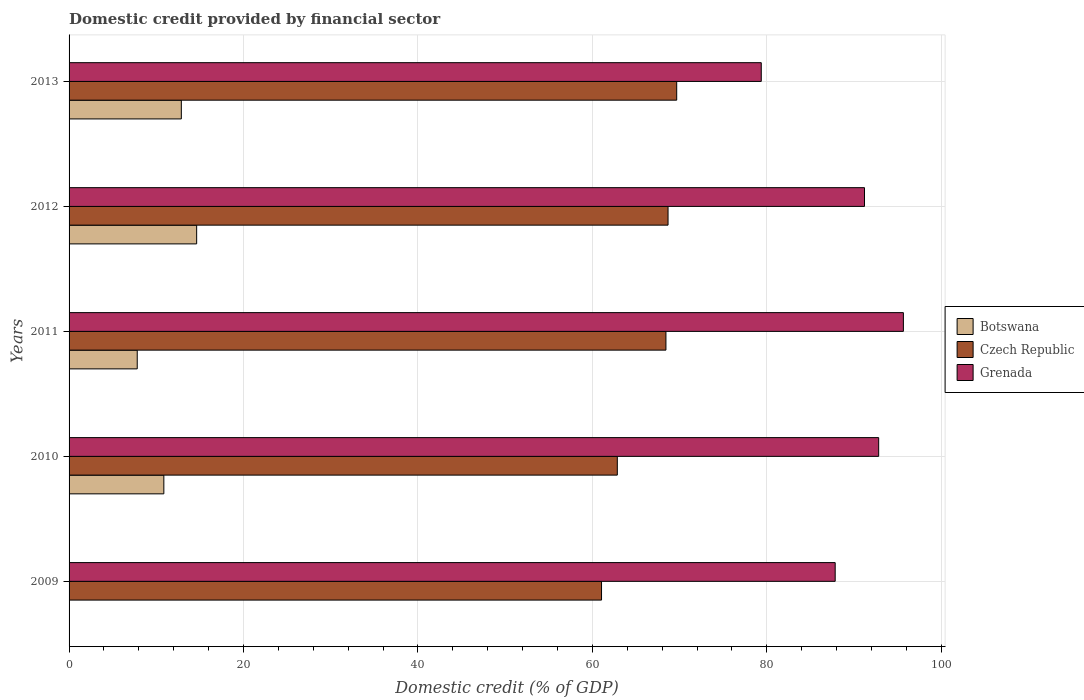Are the number of bars per tick equal to the number of legend labels?
Offer a very short reply. No. Are the number of bars on each tick of the Y-axis equal?
Offer a very short reply. No. What is the domestic credit in Grenada in 2010?
Provide a short and direct response. 92.83. Across all years, what is the maximum domestic credit in Grenada?
Your response must be concise. 95.66. In which year was the domestic credit in Grenada maximum?
Give a very brief answer. 2011. What is the total domestic credit in Czech Republic in the graph?
Make the answer very short. 330.69. What is the difference between the domestic credit in Botswana in 2011 and that in 2012?
Ensure brevity in your answer.  -6.81. What is the difference between the domestic credit in Botswana in 2011 and the domestic credit in Grenada in 2013?
Keep it short and to the point. -71.55. What is the average domestic credit in Grenada per year?
Your response must be concise. 89.38. In the year 2011, what is the difference between the domestic credit in Botswana and domestic credit in Czech Republic?
Provide a short and direct response. -60.62. In how many years, is the domestic credit in Botswana greater than 84 %?
Offer a terse response. 0. What is the ratio of the domestic credit in Botswana in 2011 to that in 2012?
Ensure brevity in your answer.  0.53. Is the domestic credit in Botswana in 2011 less than that in 2013?
Provide a short and direct response. Yes. What is the difference between the highest and the second highest domestic credit in Czech Republic?
Your response must be concise. 0.99. What is the difference between the highest and the lowest domestic credit in Botswana?
Ensure brevity in your answer.  14.63. In how many years, is the domestic credit in Grenada greater than the average domestic credit in Grenada taken over all years?
Your response must be concise. 3. Is it the case that in every year, the sum of the domestic credit in Botswana and domestic credit in Grenada is greater than the domestic credit in Czech Republic?
Give a very brief answer. Yes. How many years are there in the graph?
Ensure brevity in your answer.  5. What is the difference between two consecutive major ticks on the X-axis?
Make the answer very short. 20. Does the graph contain any zero values?
Provide a short and direct response. Yes. Does the graph contain grids?
Keep it short and to the point. Yes. What is the title of the graph?
Give a very brief answer. Domestic credit provided by financial sector. What is the label or title of the X-axis?
Provide a succinct answer. Domestic credit (% of GDP). What is the Domestic credit (% of GDP) in Czech Republic in 2009?
Offer a terse response. 61.05. What is the Domestic credit (% of GDP) in Grenada in 2009?
Provide a succinct answer. 87.84. What is the Domestic credit (% of GDP) in Botswana in 2010?
Offer a very short reply. 10.87. What is the Domestic credit (% of GDP) in Czech Republic in 2010?
Provide a succinct answer. 62.86. What is the Domestic credit (% of GDP) in Grenada in 2010?
Make the answer very short. 92.83. What is the Domestic credit (% of GDP) of Botswana in 2011?
Ensure brevity in your answer.  7.82. What is the Domestic credit (% of GDP) in Czech Republic in 2011?
Give a very brief answer. 68.44. What is the Domestic credit (% of GDP) of Grenada in 2011?
Your answer should be very brief. 95.66. What is the Domestic credit (% of GDP) of Botswana in 2012?
Your answer should be very brief. 14.63. What is the Domestic credit (% of GDP) in Czech Republic in 2012?
Provide a succinct answer. 68.68. What is the Domestic credit (% of GDP) in Grenada in 2012?
Offer a very short reply. 91.2. What is the Domestic credit (% of GDP) in Botswana in 2013?
Provide a succinct answer. 12.87. What is the Domestic credit (% of GDP) of Czech Republic in 2013?
Offer a very short reply. 69.67. What is the Domestic credit (% of GDP) of Grenada in 2013?
Provide a succinct answer. 79.37. Across all years, what is the maximum Domestic credit (% of GDP) in Botswana?
Ensure brevity in your answer.  14.63. Across all years, what is the maximum Domestic credit (% of GDP) of Czech Republic?
Offer a terse response. 69.67. Across all years, what is the maximum Domestic credit (% of GDP) in Grenada?
Your answer should be compact. 95.66. Across all years, what is the minimum Domestic credit (% of GDP) in Botswana?
Your answer should be very brief. 0. Across all years, what is the minimum Domestic credit (% of GDP) in Czech Republic?
Your response must be concise. 61.05. Across all years, what is the minimum Domestic credit (% of GDP) in Grenada?
Provide a succinct answer. 79.37. What is the total Domestic credit (% of GDP) of Botswana in the graph?
Provide a short and direct response. 46.18. What is the total Domestic credit (% of GDP) in Czech Republic in the graph?
Keep it short and to the point. 330.69. What is the total Domestic credit (% of GDP) in Grenada in the graph?
Offer a terse response. 446.9. What is the difference between the Domestic credit (% of GDP) in Czech Republic in 2009 and that in 2010?
Your answer should be compact. -1.81. What is the difference between the Domestic credit (% of GDP) of Grenada in 2009 and that in 2010?
Your answer should be compact. -4.99. What is the difference between the Domestic credit (% of GDP) of Czech Republic in 2009 and that in 2011?
Make the answer very short. -7.39. What is the difference between the Domestic credit (% of GDP) of Grenada in 2009 and that in 2011?
Your answer should be very brief. -7.82. What is the difference between the Domestic credit (% of GDP) in Czech Republic in 2009 and that in 2012?
Your answer should be compact. -7.63. What is the difference between the Domestic credit (% of GDP) in Grenada in 2009 and that in 2012?
Your answer should be very brief. -3.36. What is the difference between the Domestic credit (% of GDP) in Czech Republic in 2009 and that in 2013?
Your answer should be very brief. -8.62. What is the difference between the Domestic credit (% of GDP) in Grenada in 2009 and that in 2013?
Keep it short and to the point. 8.48. What is the difference between the Domestic credit (% of GDP) of Botswana in 2010 and that in 2011?
Provide a succinct answer. 3.05. What is the difference between the Domestic credit (% of GDP) in Czech Republic in 2010 and that in 2011?
Ensure brevity in your answer.  -5.58. What is the difference between the Domestic credit (% of GDP) of Grenada in 2010 and that in 2011?
Give a very brief answer. -2.83. What is the difference between the Domestic credit (% of GDP) of Botswana in 2010 and that in 2012?
Provide a succinct answer. -3.76. What is the difference between the Domestic credit (% of GDP) in Czech Republic in 2010 and that in 2012?
Provide a succinct answer. -5.82. What is the difference between the Domestic credit (% of GDP) of Grenada in 2010 and that in 2012?
Provide a succinct answer. 1.62. What is the difference between the Domestic credit (% of GDP) of Botswana in 2010 and that in 2013?
Keep it short and to the point. -2. What is the difference between the Domestic credit (% of GDP) of Czech Republic in 2010 and that in 2013?
Make the answer very short. -6.81. What is the difference between the Domestic credit (% of GDP) in Grenada in 2010 and that in 2013?
Provide a succinct answer. 13.46. What is the difference between the Domestic credit (% of GDP) in Botswana in 2011 and that in 2012?
Provide a succinct answer. -6.81. What is the difference between the Domestic credit (% of GDP) of Czech Republic in 2011 and that in 2012?
Provide a succinct answer. -0.24. What is the difference between the Domestic credit (% of GDP) of Grenada in 2011 and that in 2012?
Provide a short and direct response. 4.46. What is the difference between the Domestic credit (% of GDP) of Botswana in 2011 and that in 2013?
Provide a short and direct response. -5.05. What is the difference between the Domestic credit (% of GDP) of Czech Republic in 2011 and that in 2013?
Make the answer very short. -1.23. What is the difference between the Domestic credit (% of GDP) in Grenada in 2011 and that in 2013?
Give a very brief answer. 16.29. What is the difference between the Domestic credit (% of GDP) in Botswana in 2012 and that in 2013?
Your answer should be very brief. 1.76. What is the difference between the Domestic credit (% of GDP) of Czech Republic in 2012 and that in 2013?
Your answer should be compact. -0.99. What is the difference between the Domestic credit (% of GDP) in Grenada in 2012 and that in 2013?
Offer a terse response. 11.84. What is the difference between the Domestic credit (% of GDP) in Czech Republic in 2009 and the Domestic credit (% of GDP) in Grenada in 2010?
Provide a succinct answer. -31.78. What is the difference between the Domestic credit (% of GDP) in Czech Republic in 2009 and the Domestic credit (% of GDP) in Grenada in 2011?
Keep it short and to the point. -34.61. What is the difference between the Domestic credit (% of GDP) in Czech Republic in 2009 and the Domestic credit (% of GDP) in Grenada in 2012?
Offer a very short reply. -30.15. What is the difference between the Domestic credit (% of GDP) in Czech Republic in 2009 and the Domestic credit (% of GDP) in Grenada in 2013?
Your answer should be very brief. -18.32. What is the difference between the Domestic credit (% of GDP) of Botswana in 2010 and the Domestic credit (% of GDP) of Czech Republic in 2011?
Provide a succinct answer. -57.57. What is the difference between the Domestic credit (% of GDP) in Botswana in 2010 and the Domestic credit (% of GDP) in Grenada in 2011?
Keep it short and to the point. -84.79. What is the difference between the Domestic credit (% of GDP) of Czech Republic in 2010 and the Domestic credit (% of GDP) of Grenada in 2011?
Give a very brief answer. -32.8. What is the difference between the Domestic credit (% of GDP) of Botswana in 2010 and the Domestic credit (% of GDP) of Czech Republic in 2012?
Provide a short and direct response. -57.81. What is the difference between the Domestic credit (% of GDP) of Botswana in 2010 and the Domestic credit (% of GDP) of Grenada in 2012?
Make the answer very short. -80.34. What is the difference between the Domestic credit (% of GDP) of Czech Republic in 2010 and the Domestic credit (% of GDP) of Grenada in 2012?
Offer a terse response. -28.34. What is the difference between the Domestic credit (% of GDP) in Botswana in 2010 and the Domestic credit (% of GDP) in Czech Republic in 2013?
Keep it short and to the point. -58.8. What is the difference between the Domestic credit (% of GDP) of Botswana in 2010 and the Domestic credit (% of GDP) of Grenada in 2013?
Your answer should be very brief. -68.5. What is the difference between the Domestic credit (% of GDP) of Czech Republic in 2010 and the Domestic credit (% of GDP) of Grenada in 2013?
Ensure brevity in your answer.  -16.51. What is the difference between the Domestic credit (% of GDP) of Botswana in 2011 and the Domestic credit (% of GDP) of Czech Republic in 2012?
Give a very brief answer. -60.86. What is the difference between the Domestic credit (% of GDP) of Botswana in 2011 and the Domestic credit (% of GDP) of Grenada in 2012?
Offer a terse response. -83.39. What is the difference between the Domestic credit (% of GDP) of Czech Republic in 2011 and the Domestic credit (% of GDP) of Grenada in 2012?
Provide a succinct answer. -22.77. What is the difference between the Domestic credit (% of GDP) of Botswana in 2011 and the Domestic credit (% of GDP) of Czech Republic in 2013?
Provide a short and direct response. -61.85. What is the difference between the Domestic credit (% of GDP) of Botswana in 2011 and the Domestic credit (% of GDP) of Grenada in 2013?
Offer a very short reply. -71.55. What is the difference between the Domestic credit (% of GDP) in Czech Republic in 2011 and the Domestic credit (% of GDP) in Grenada in 2013?
Keep it short and to the point. -10.93. What is the difference between the Domestic credit (% of GDP) of Botswana in 2012 and the Domestic credit (% of GDP) of Czech Republic in 2013?
Your answer should be very brief. -55.04. What is the difference between the Domestic credit (% of GDP) of Botswana in 2012 and the Domestic credit (% of GDP) of Grenada in 2013?
Offer a very short reply. -64.74. What is the difference between the Domestic credit (% of GDP) of Czech Republic in 2012 and the Domestic credit (% of GDP) of Grenada in 2013?
Your answer should be very brief. -10.69. What is the average Domestic credit (% of GDP) of Botswana per year?
Your answer should be compact. 9.24. What is the average Domestic credit (% of GDP) of Czech Republic per year?
Make the answer very short. 66.14. What is the average Domestic credit (% of GDP) in Grenada per year?
Your answer should be compact. 89.38. In the year 2009, what is the difference between the Domestic credit (% of GDP) in Czech Republic and Domestic credit (% of GDP) in Grenada?
Your answer should be very brief. -26.79. In the year 2010, what is the difference between the Domestic credit (% of GDP) in Botswana and Domestic credit (% of GDP) in Czech Republic?
Give a very brief answer. -51.99. In the year 2010, what is the difference between the Domestic credit (% of GDP) of Botswana and Domestic credit (% of GDP) of Grenada?
Provide a succinct answer. -81.96. In the year 2010, what is the difference between the Domestic credit (% of GDP) in Czech Republic and Domestic credit (% of GDP) in Grenada?
Give a very brief answer. -29.97. In the year 2011, what is the difference between the Domestic credit (% of GDP) in Botswana and Domestic credit (% of GDP) in Czech Republic?
Keep it short and to the point. -60.62. In the year 2011, what is the difference between the Domestic credit (% of GDP) of Botswana and Domestic credit (% of GDP) of Grenada?
Keep it short and to the point. -87.85. In the year 2011, what is the difference between the Domestic credit (% of GDP) in Czech Republic and Domestic credit (% of GDP) in Grenada?
Make the answer very short. -27.22. In the year 2012, what is the difference between the Domestic credit (% of GDP) in Botswana and Domestic credit (% of GDP) in Czech Republic?
Provide a short and direct response. -54.05. In the year 2012, what is the difference between the Domestic credit (% of GDP) in Botswana and Domestic credit (% of GDP) in Grenada?
Give a very brief answer. -76.57. In the year 2012, what is the difference between the Domestic credit (% of GDP) of Czech Republic and Domestic credit (% of GDP) of Grenada?
Provide a succinct answer. -22.52. In the year 2013, what is the difference between the Domestic credit (% of GDP) in Botswana and Domestic credit (% of GDP) in Czech Republic?
Give a very brief answer. -56.8. In the year 2013, what is the difference between the Domestic credit (% of GDP) of Botswana and Domestic credit (% of GDP) of Grenada?
Keep it short and to the point. -66.5. In the year 2013, what is the difference between the Domestic credit (% of GDP) in Czech Republic and Domestic credit (% of GDP) in Grenada?
Your answer should be compact. -9.7. What is the ratio of the Domestic credit (% of GDP) of Czech Republic in 2009 to that in 2010?
Make the answer very short. 0.97. What is the ratio of the Domestic credit (% of GDP) in Grenada in 2009 to that in 2010?
Your answer should be very brief. 0.95. What is the ratio of the Domestic credit (% of GDP) in Czech Republic in 2009 to that in 2011?
Ensure brevity in your answer.  0.89. What is the ratio of the Domestic credit (% of GDP) of Grenada in 2009 to that in 2011?
Provide a succinct answer. 0.92. What is the ratio of the Domestic credit (% of GDP) of Czech Republic in 2009 to that in 2012?
Make the answer very short. 0.89. What is the ratio of the Domestic credit (% of GDP) of Grenada in 2009 to that in 2012?
Keep it short and to the point. 0.96. What is the ratio of the Domestic credit (% of GDP) of Czech Republic in 2009 to that in 2013?
Provide a short and direct response. 0.88. What is the ratio of the Domestic credit (% of GDP) of Grenada in 2009 to that in 2013?
Give a very brief answer. 1.11. What is the ratio of the Domestic credit (% of GDP) of Botswana in 2010 to that in 2011?
Your answer should be very brief. 1.39. What is the ratio of the Domestic credit (% of GDP) in Czech Republic in 2010 to that in 2011?
Make the answer very short. 0.92. What is the ratio of the Domestic credit (% of GDP) in Grenada in 2010 to that in 2011?
Offer a terse response. 0.97. What is the ratio of the Domestic credit (% of GDP) in Botswana in 2010 to that in 2012?
Your response must be concise. 0.74. What is the ratio of the Domestic credit (% of GDP) of Czech Republic in 2010 to that in 2012?
Your answer should be very brief. 0.92. What is the ratio of the Domestic credit (% of GDP) of Grenada in 2010 to that in 2012?
Your answer should be very brief. 1.02. What is the ratio of the Domestic credit (% of GDP) of Botswana in 2010 to that in 2013?
Offer a terse response. 0.84. What is the ratio of the Domestic credit (% of GDP) in Czech Republic in 2010 to that in 2013?
Your answer should be very brief. 0.9. What is the ratio of the Domestic credit (% of GDP) of Grenada in 2010 to that in 2013?
Offer a very short reply. 1.17. What is the ratio of the Domestic credit (% of GDP) in Botswana in 2011 to that in 2012?
Provide a short and direct response. 0.53. What is the ratio of the Domestic credit (% of GDP) of Czech Republic in 2011 to that in 2012?
Your response must be concise. 1. What is the ratio of the Domestic credit (% of GDP) of Grenada in 2011 to that in 2012?
Offer a very short reply. 1.05. What is the ratio of the Domestic credit (% of GDP) of Botswana in 2011 to that in 2013?
Give a very brief answer. 0.61. What is the ratio of the Domestic credit (% of GDP) in Czech Republic in 2011 to that in 2013?
Your answer should be compact. 0.98. What is the ratio of the Domestic credit (% of GDP) in Grenada in 2011 to that in 2013?
Provide a succinct answer. 1.21. What is the ratio of the Domestic credit (% of GDP) of Botswana in 2012 to that in 2013?
Make the answer very short. 1.14. What is the ratio of the Domestic credit (% of GDP) in Czech Republic in 2012 to that in 2013?
Give a very brief answer. 0.99. What is the ratio of the Domestic credit (% of GDP) in Grenada in 2012 to that in 2013?
Your response must be concise. 1.15. What is the difference between the highest and the second highest Domestic credit (% of GDP) in Botswana?
Your response must be concise. 1.76. What is the difference between the highest and the second highest Domestic credit (% of GDP) of Czech Republic?
Provide a short and direct response. 0.99. What is the difference between the highest and the second highest Domestic credit (% of GDP) of Grenada?
Your response must be concise. 2.83. What is the difference between the highest and the lowest Domestic credit (% of GDP) of Botswana?
Your answer should be compact. 14.63. What is the difference between the highest and the lowest Domestic credit (% of GDP) in Czech Republic?
Your answer should be very brief. 8.62. What is the difference between the highest and the lowest Domestic credit (% of GDP) in Grenada?
Your answer should be compact. 16.29. 